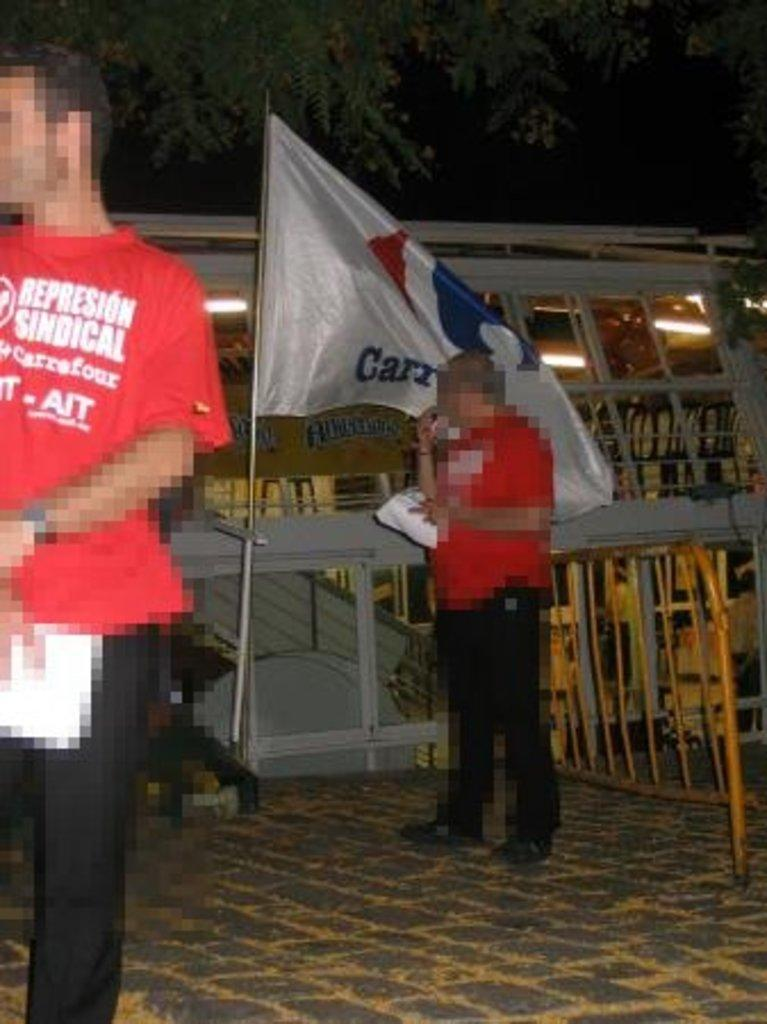What are the people in the image doing? The people in the image are standing on the ground. What can be seen in the distance behind the people? There is a building visible in the background of the image. How would you describe the lighting in the image? The background of the image is dark. What type of lace can be seen on the trees in the image? There are no trees or lace present in the image. How many scales are visible on the people in the image? The people in the image are not depicted as having scales. 